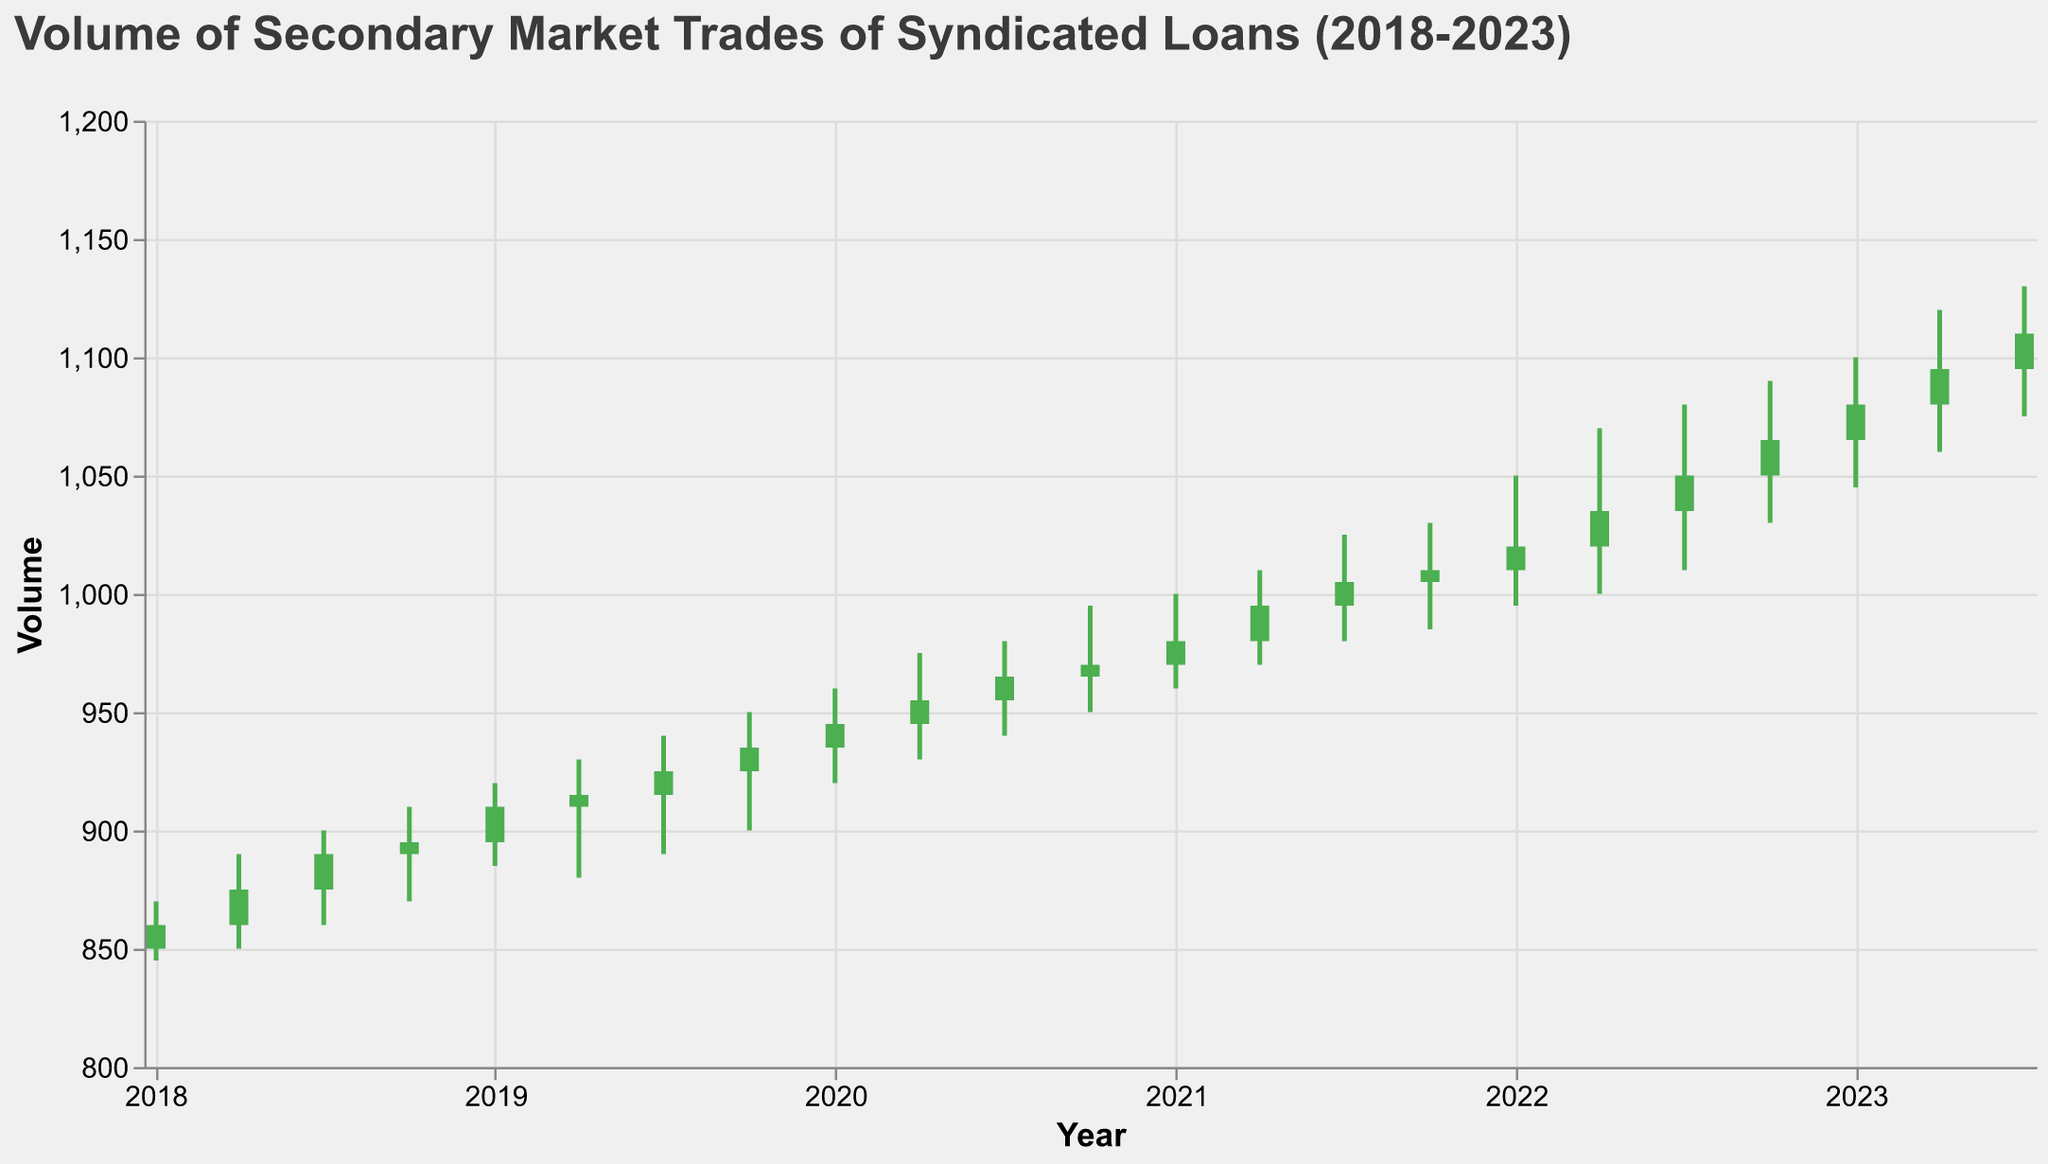What is the title of the figure? The title is usually prominently displayed at the top of the figure. It summarizes the content of the chart.
Answer: Volume of Secondary Market Trades of Syndicated Loans (2018-2023) How many years are covered in the figure? The x-axis represents the timeline and includes data from 2018 to 2023, which spans 6 years.
Answer: 6 years What is the highest volume recorded in the figure? The highest volume is indicated by the highest point on the y-axis, which is 1130. This maximum occurs during the date 2023-07-01.
Answer: 1130 Which periods saw an increase in the closing volume compared to the opening volume? In candlestick charts, a green bar (or positive change) indicates that the closing volume was higher than the opening volume. The dates with green bars are: 2018-01-02, 2018-04-01, 2018-07-01, 2018-10-01, 2019-01-01, 2019-04-01, 2019-07-01, 2019-10-01, 2020-01-01, 2020-04-01, 2020-07-01, 2020-10-01, 2021-01-01, 2021-04-01, 2021-07-01, 2022-01-01, 2022-04-01, 2022-07-01, 2022-10-01, 2023-01-01, 2023-04-01, 2023-07-01. Count these dates.
Answer: 22 periods What is the average volume at close for the entire period? To calculate the average, sum the closing volumes for all periods and divide by the number of periods. (860 + 875 + 890 + 895 + 910 + 915 + 925 + 935 + 945 + 955 + 965 + 970 + 980 + 995 + 1005 + 1010 + 1020 + 1035 + 1050 + 1065 + 1080 + 1095 + 1110) / 23 = 21665 / 23
Answer: 942.39 Between which two consecutive periods did the closing volume increase the most? Identify the difference in closing volumes between consecutive periods and find the maximum increase. Closing volumes: (875-860, 890-875, 895-890, 910-895, 915-910, 925-915, 935-925, 945-935, 955-945, 965-955, 970-965, 980-970, 995-980, 1005-995, 1010-1005, 1020-1010, 1035-1020, 1050-1035, 1065-1050, 1080-1065, 1095-1080, 1110-1095). The largest increase corresponds to 2020-01-01 to 2020-04-01 (975-955) = 20.
Answer: 2020-01-01 to 2020-04-01 Which year saw the largest overall increase in trading volume from start to end? For each year, calculate the increase from the first period's opening volume to the last period's closing volume: 2018 (860-850), 2019 (935-895), 2020 (970-945), 2021 (1010-970), 2022 (1065-1020), 2023 (1110-1080). The largest increase corresponds to 2023 (1110-1080) = 30.
Answer: 2023 During which period did the lowest low volume occur, and what was its value? Find the period with the lowest low volume by examining the "Low" values. The lowest low value is 845 on 2018-01-02.
Answer: 2018-01-02, 845 What was the range of volumes during 2021-2022? The range is calculated as the difference between the highest high and the lowest low values during the specified period. 2021-2022 range: High = 1090 (2022-10-01), Low = 960 (2021-01-01). The range is 1090 - 960 = 130.
Answer: 130 How many periods had no increase in volume (i.e., open was equal to close)? Identify periods where the opening volume is equal to the closing volume. Inspect the data and find no such periods.
Answer: 0 periods 